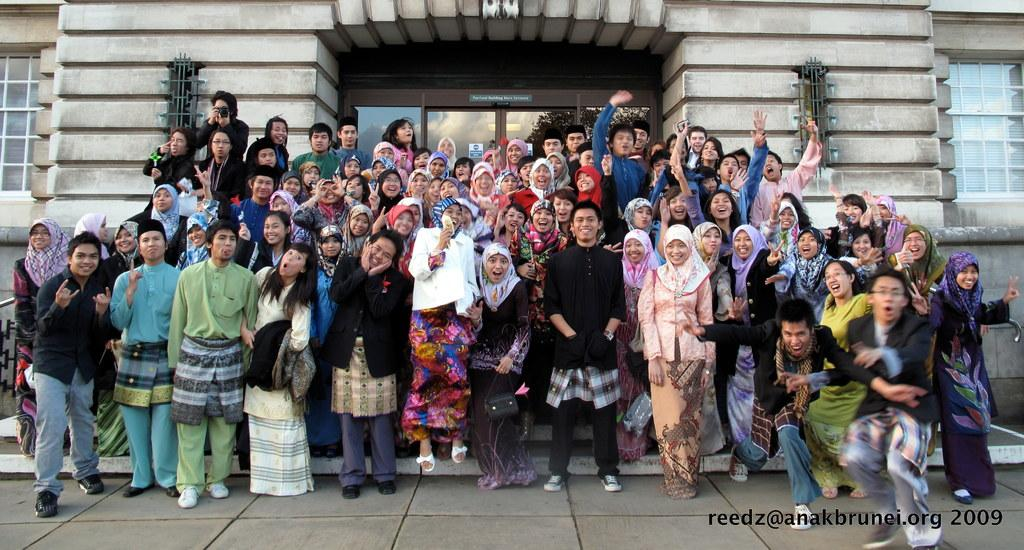What type of architectural features can be seen in the background of the image? There are windows, a glass door, and a wall visible in the background of the image. What type of photo is this? This is a group photo. How are the people in the photo posing? The people in the photo are giving different poses. Is there any text or logo visible in the image? Yes, there is a watermark at the bottom of the image. What type of curve can be seen in the image? There is no curve visible in the image. Can you see any jellyfish in the image? No, there are no jellyfish present in the image. 